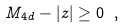Convert formula to latex. <formula><loc_0><loc_0><loc_500><loc_500>M _ { 4 d } - | z | \geq 0 \ ,</formula> 